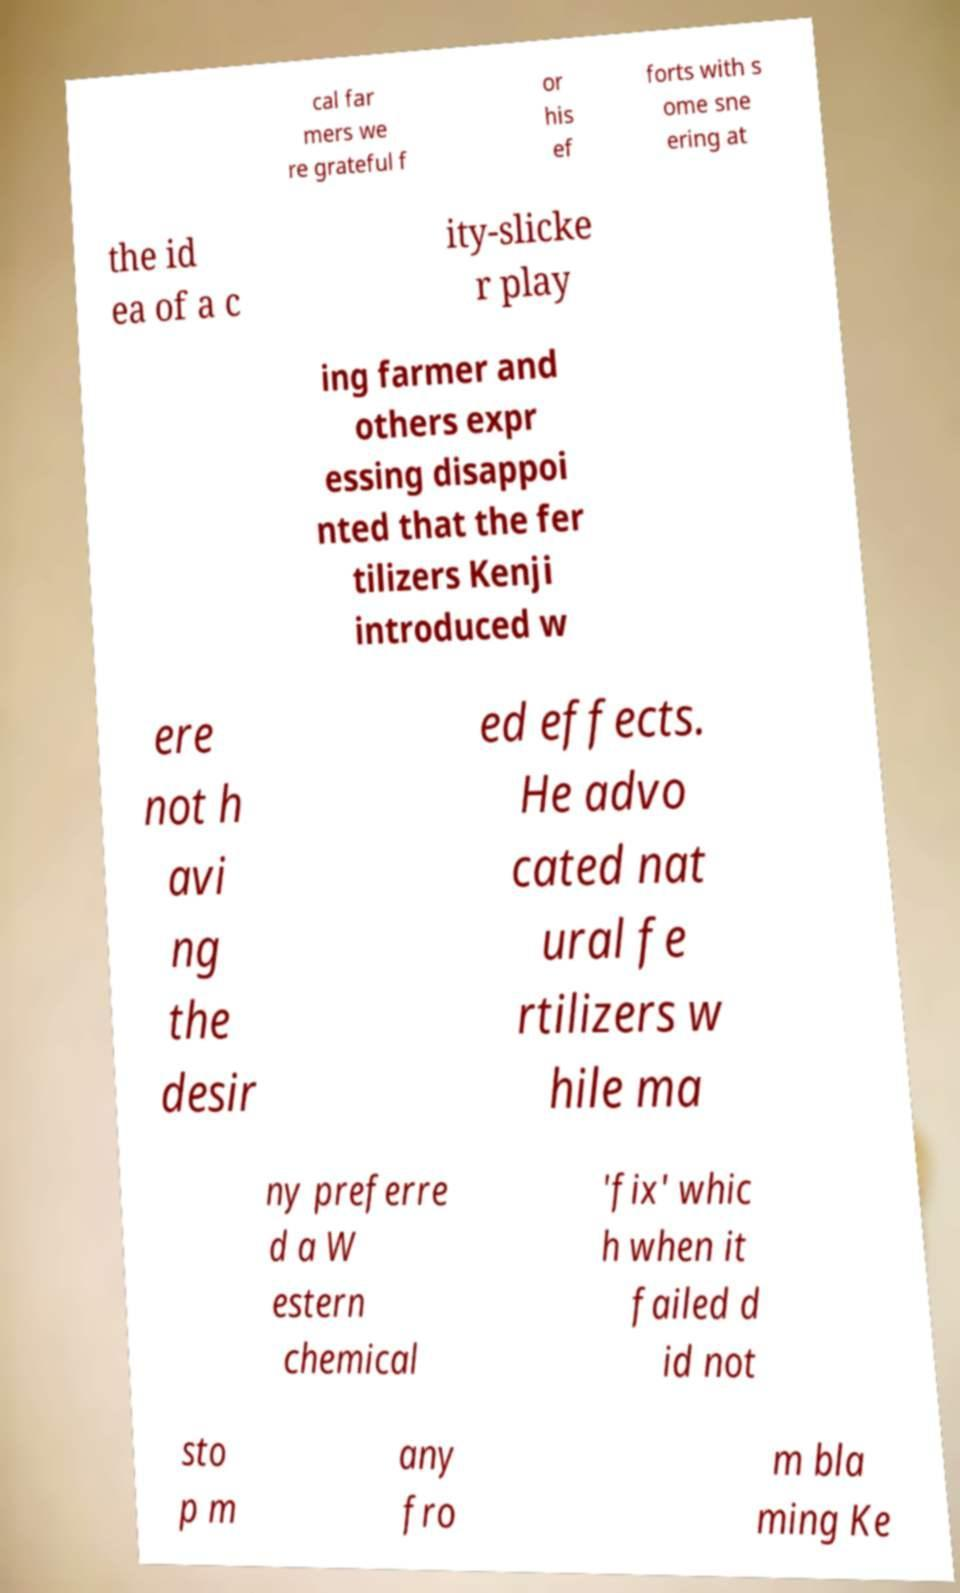Please identify and transcribe the text found in this image. cal far mers we re grateful f or his ef forts with s ome sne ering at the id ea of a c ity-slicke r play ing farmer and others expr essing disappoi nted that the fer tilizers Kenji introduced w ere not h avi ng the desir ed effects. He advo cated nat ural fe rtilizers w hile ma ny preferre d a W estern chemical 'fix' whic h when it failed d id not sto p m any fro m bla ming Ke 